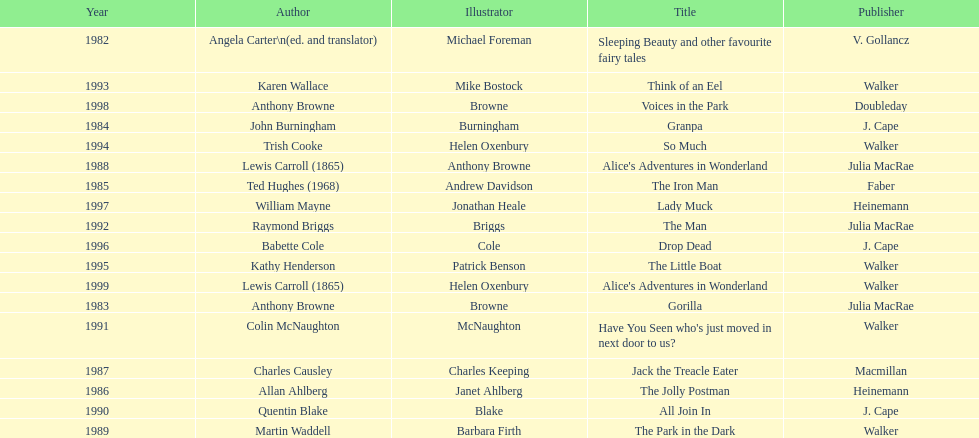What are the number of kurt maschler awards helen oxenbury has won? 2. 